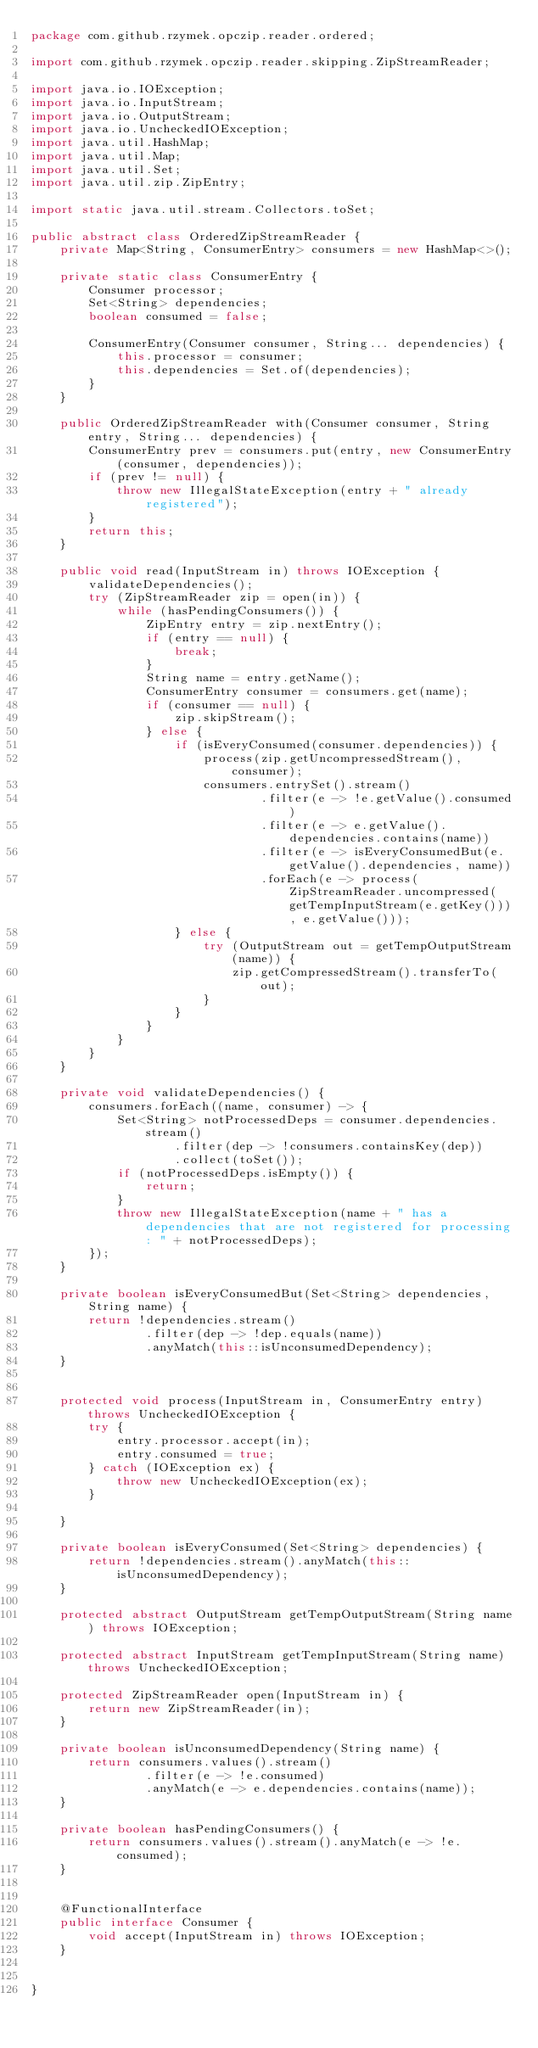<code> <loc_0><loc_0><loc_500><loc_500><_Java_>package com.github.rzymek.opczip.reader.ordered;

import com.github.rzymek.opczip.reader.skipping.ZipStreamReader;

import java.io.IOException;
import java.io.InputStream;
import java.io.OutputStream;
import java.io.UncheckedIOException;
import java.util.HashMap;
import java.util.Map;
import java.util.Set;
import java.util.zip.ZipEntry;

import static java.util.stream.Collectors.toSet;

public abstract class OrderedZipStreamReader {
    private Map<String, ConsumerEntry> consumers = new HashMap<>();

    private static class ConsumerEntry {
        Consumer processor;
        Set<String> dependencies;
        boolean consumed = false;

        ConsumerEntry(Consumer consumer, String... dependencies) {
            this.processor = consumer;
            this.dependencies = Set.of(dependencies);
        }
    }

    public OrderedZipStreamReader with(Consumer consumer, String entry, String... dependencies) {
        ConsumerEntry prev = consumers.put(entry, new ConsumerEntry(consumer, dependencies));
        if (prev != null) {
            throw new IllegalStateException(entry + " already registered");
        }
        return this;
    }

    public void read(InputStream in) throws IOException {
        validateDependencies();
        try (ZipStreamReader zip = open(in)) {
            while (hasPendingConsumers()) {
                ZipEntry entry = zip.nextEntry();
                if (entry == null) {
                    break;
                }
                String name = entry.getName();
                ConsumerEntry consumer = consumers.get(name);
                if (consumer == null) {
                    zip.skipStream();
                } else {
                    if (isEveryConsumed(consumer.dependencies)) {
                        process(zip.getUncompressedStream(), consumer);
                        consumers.entrySet().stream()
                                .filter(e -> !e.getValue().consumed)
                                .filter(e -> e.getValue().dependencies.contains(name))
                                .filter(e -> isEveryConsumedBut(e.getValue().dependencies, name))
                                .forEach(e -> process(ZipStreamReader.uncompressed(getTempInputStream(e.getKey())), e.getValue()));
                    } else {
                        try (OutputStream out = getTempOutputStream(name)) {
                            zip.getCompressedStream().transferTo(out);
                        }
                    }
                }
            }
        }
    }

    private void validateDependencies() {
        consumers.forEach((name, consumer) -> {
            Set<String> notProcessedDeps = consumer.dependencies.stream()
                    .filter(dep -> !consumers.containsKey(dep))
                    .collect(toSet());
            if (notProcessedDeps.isEmpty()) {
                return;
            }
            throw new IllegalStateException(name + " has a dependencies that are not registered for processing: " + notProcessedDeps);
        });
    }

    private boolean isEveryConsumedBut(Set<String> dependencies, String name) {
        return !dependencies.stream()
                .filter(dep -> !dep.equals(name))
                .anyMatch(this::isUnconsumedDependency);
    }


    protected void process(InputStream in, ConsumerEntry entry) throws UncheckedIOException {
        try {
            entry.processor.accept(in);
            entry.consumed = true;
        } catch (IOException ex) {
            throw new UncheckedIOException(ex);
        }

    }

    private boolean isEveryConsumed(Set<String> dependencies) {
        return !dependencies.stream().anyMatch(this::isUnconsumedDependency);
    }

    protected abstract OutputStream getTempOutputStream(String name) throws IOException;

    protected abstract InputStream getTempInputStream(String name) throws UncheckedIOException;

    protected ZipStreamReader open(InputStream in) {
        return new ZipStreamReader(in);
    }

    private boolean isUnconsumedDependency(String name) {
        return consumers.values().stream()
                .filter(e -> !e.consumed)
                .anyMatch(e -> e.dependencies.contains(name));
    }

    private boolean hasPendingConsumers() {
        return consumers.values().stream().anyMatch(e -> !e.consumed);
    }


    @FunctionalInterface
    public interface Consumer {
        void accept(InputStream in) throws IOException;
    }


}
</code> 